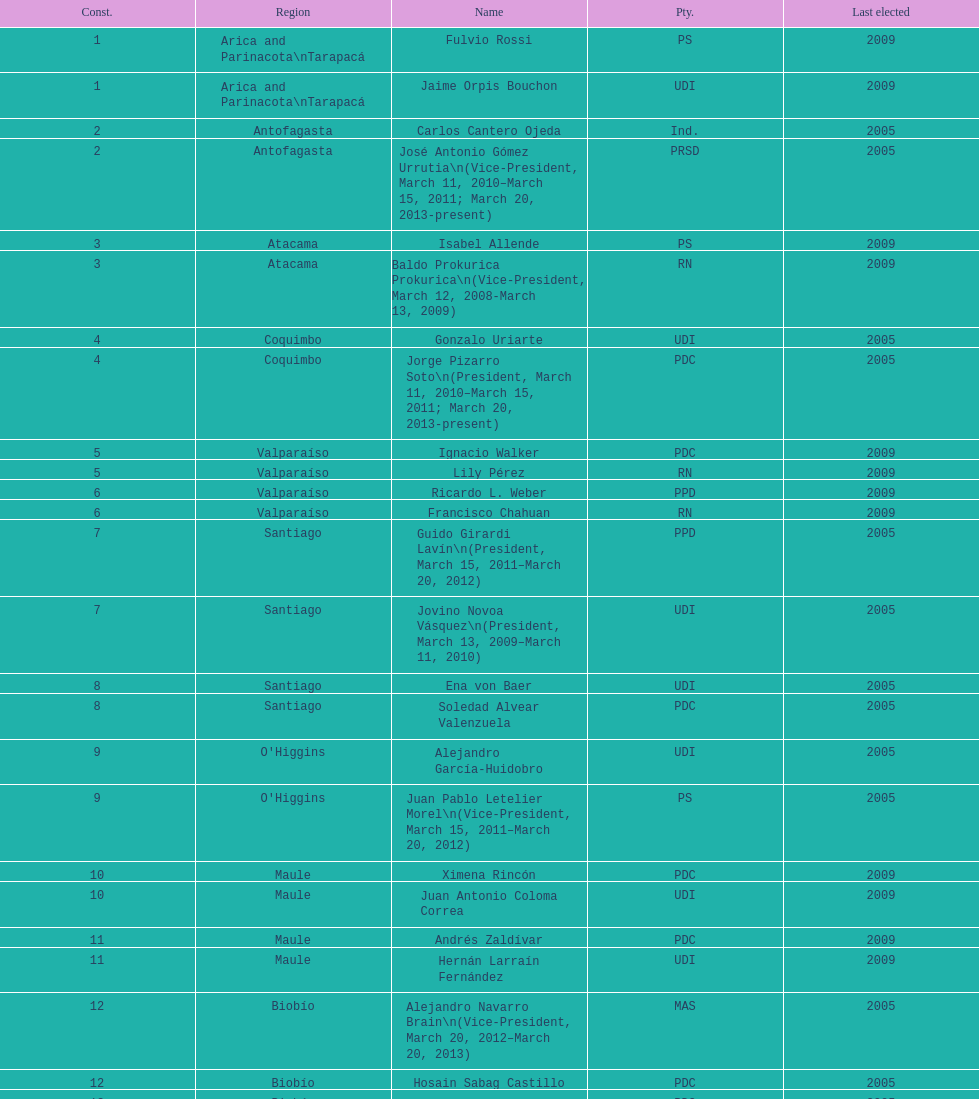Who was not last elected in either 2005 or 2009? Antonio Horvath Kiss. 